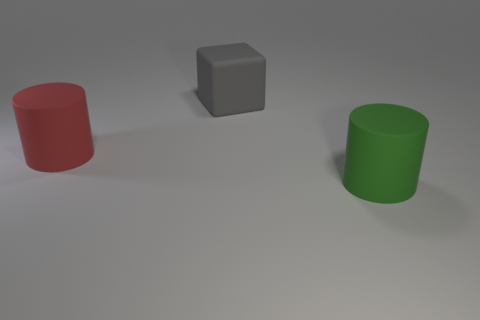Subtract all cyan blocks. Subtract all gray cylinders. How many blocks are left? 1 Add 3 red spheres. How many objects exist? 6 Subtract all cylinders. How many objects are left? 1 Add 3 blocks. How many blocks exist? 4 Subtract 0 gray cylinders. How many objects are left? 3 Subtract all green objects. Subtract all large gray metal cylinders. How many objects are left? 2 Add 3 large green things. How many large green things are left? 4 